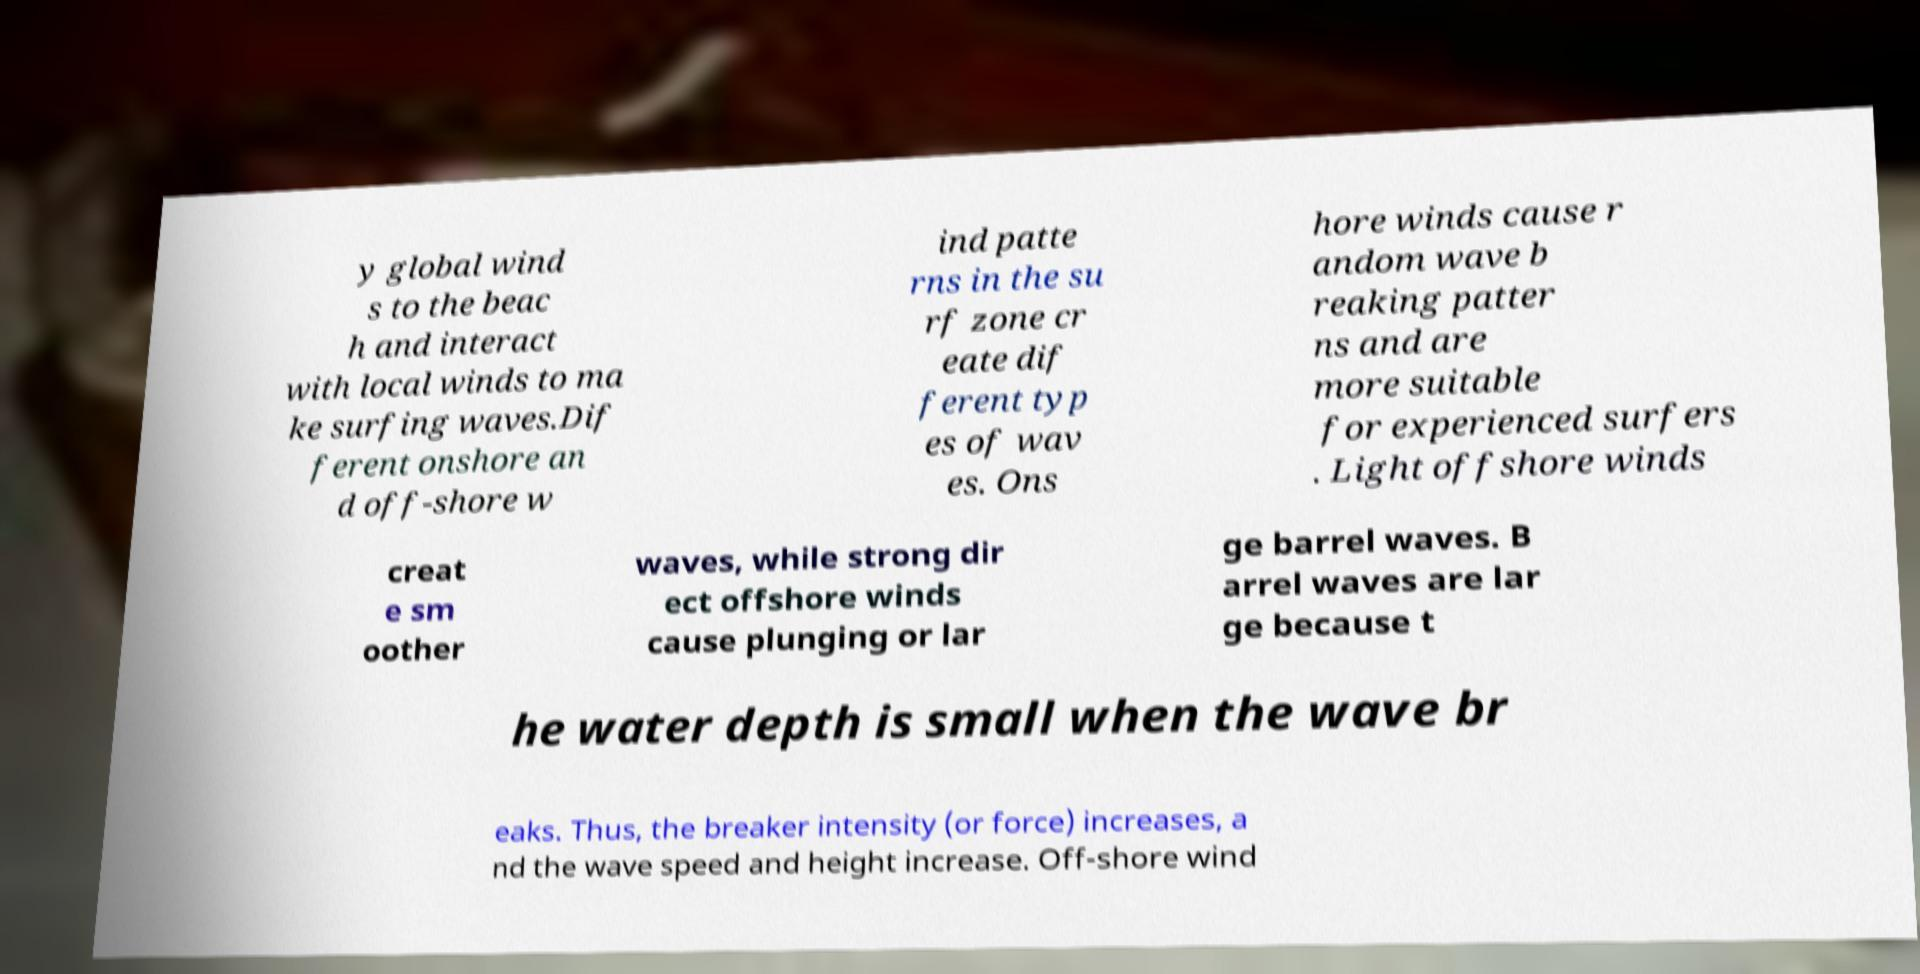Could you extract and type out the text from this image? y global wind s to the beac h and interact with local winds to ma ke surfing waves.Dif ferent onshore an d off-shore w ind patte rns in the su rf zone cr eate dif ferent typ es of wav es. Ons hore winds cause r andom wave b reaking patter ns and are more suitable for experienced surfers . Light offshore winds creat e sm oother waves, while strong dir ect offshore winds cause plunging or lar ge barrel waves. B arrel waves are lar ge because t he water depth is small when the wave br eaks. Thus, the breaker intensity (or force) increases, a nd the wave speed and height increase. Off-shore wind 